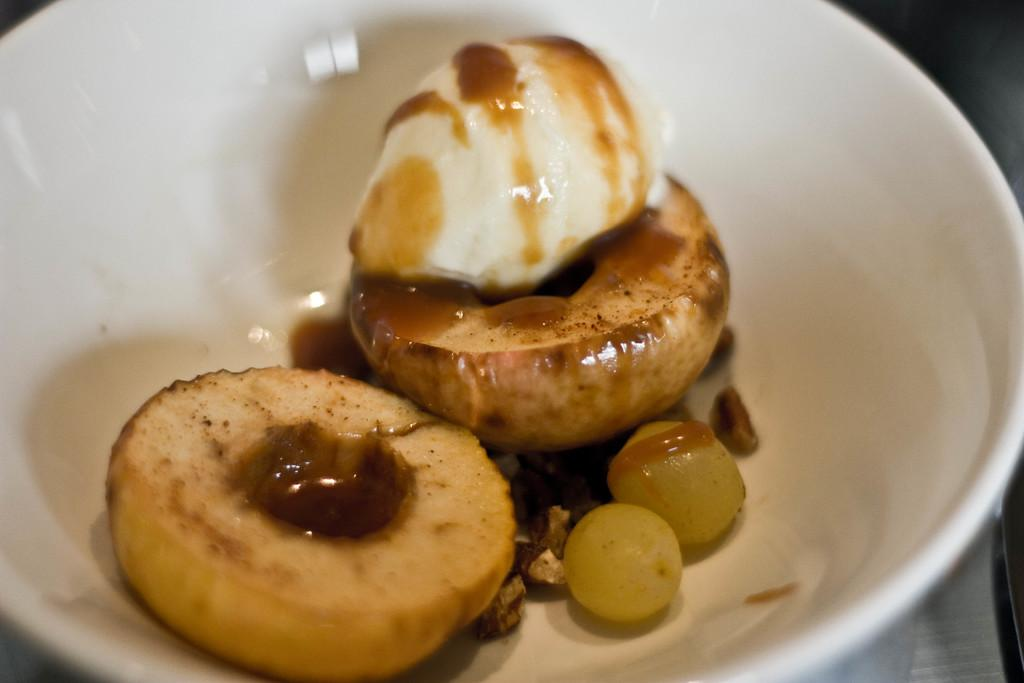What is the main subject of the image? There is a food item in the image. How is the food item presented in the image? The food is in a bowl. What color is the nail painted in the image? There is no nail present in the image. How does the knee bend in the image? There is no knee present in the image. 